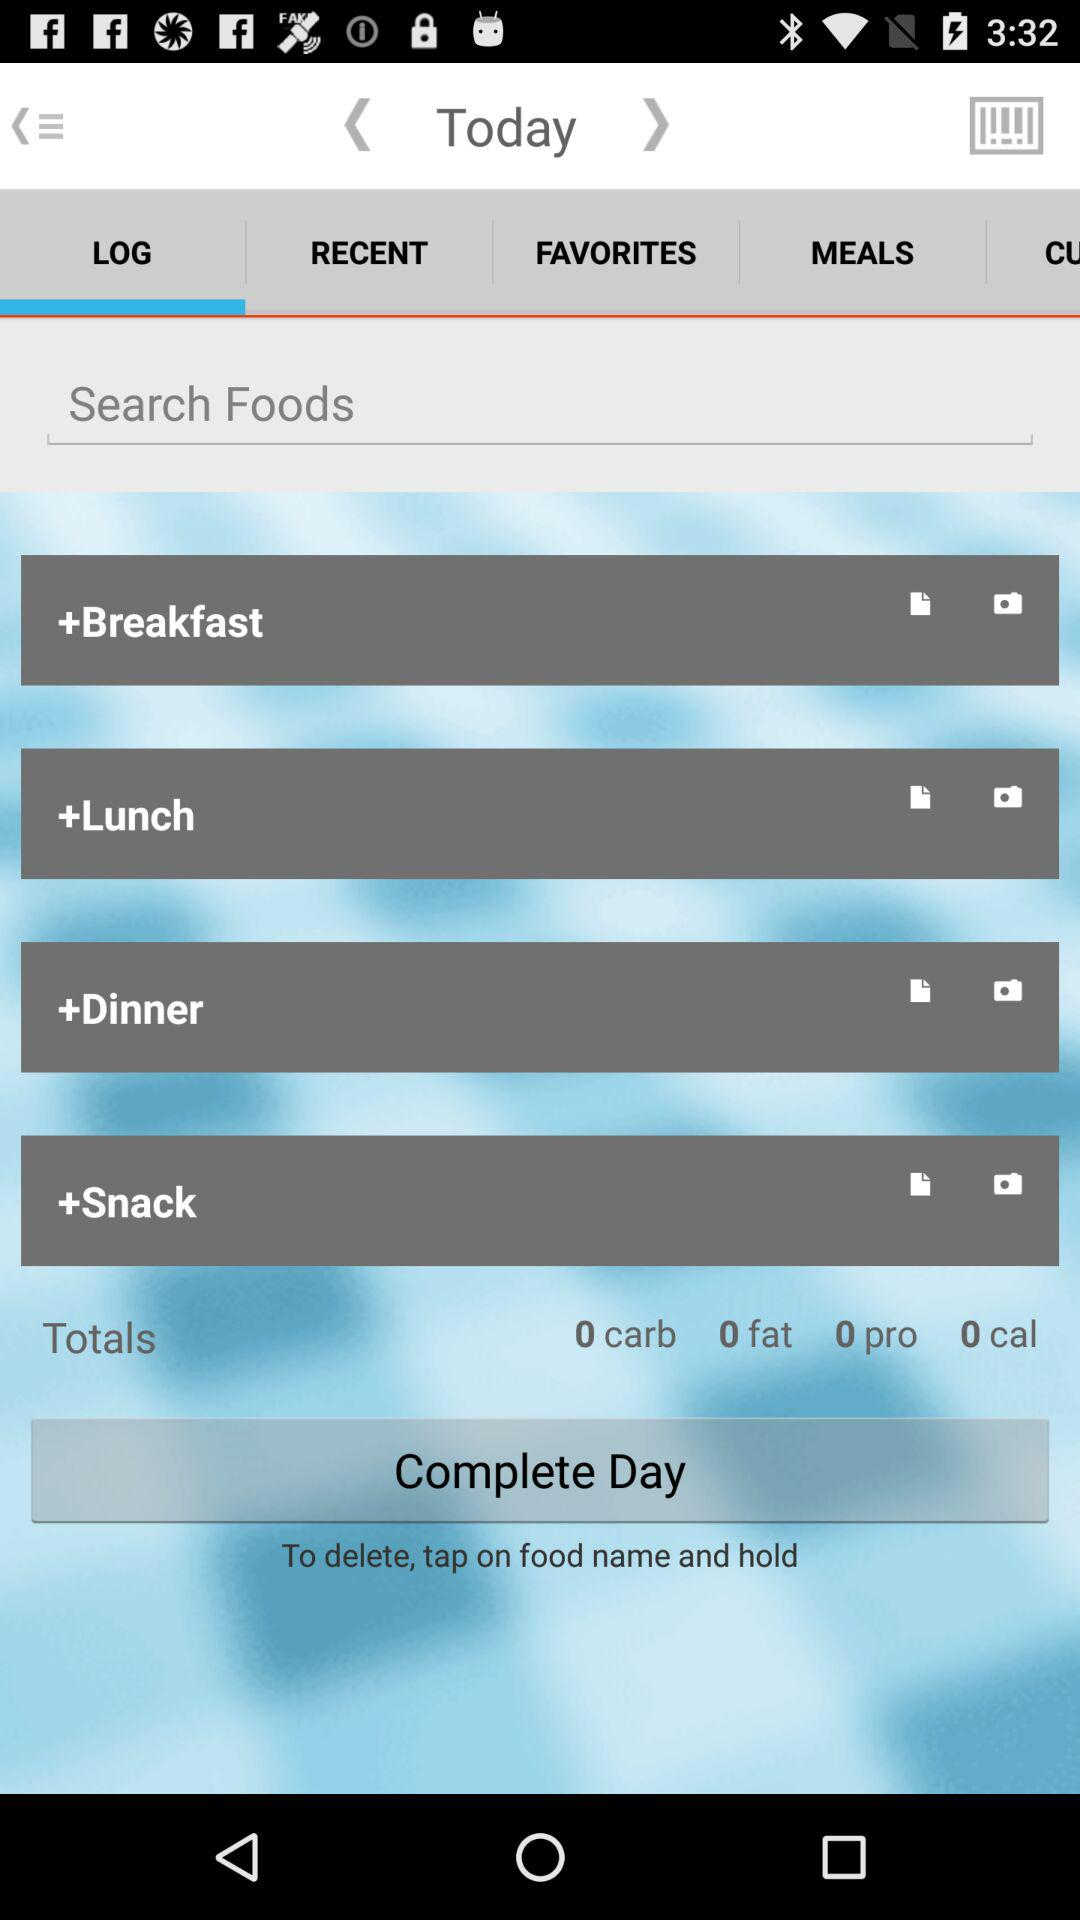What is the total fat? The total fat is 0. 